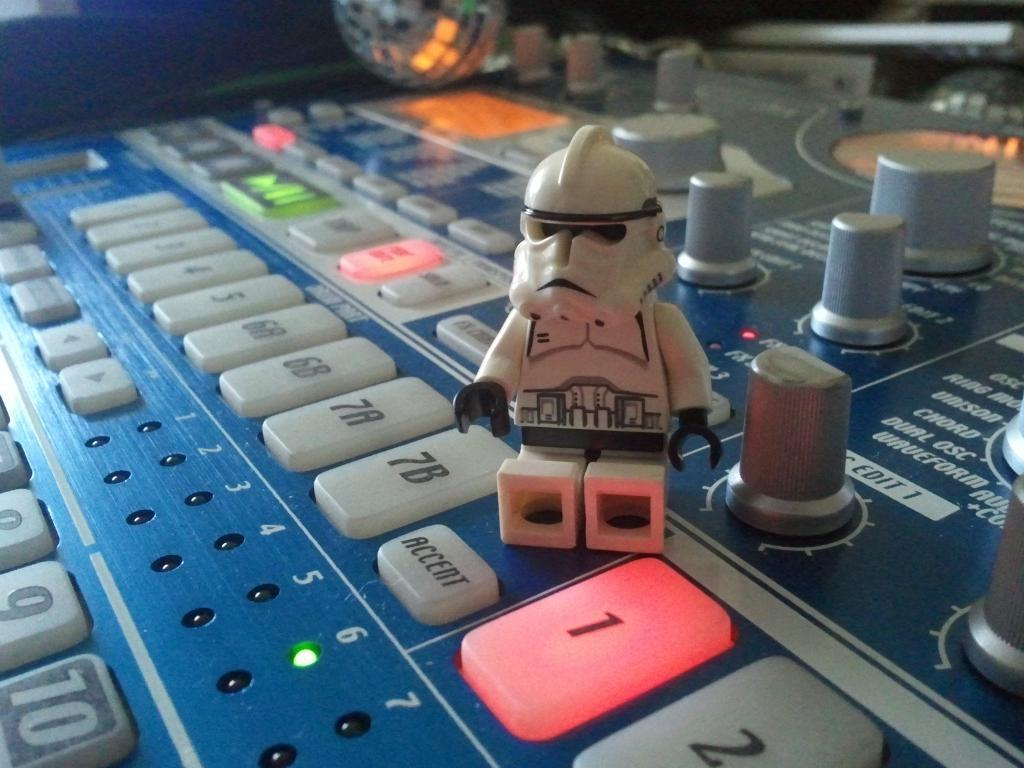<image>
Create a compact narrative representing the image presented. A lego storm trooper beside a "1" button that is lit up red on a console. 